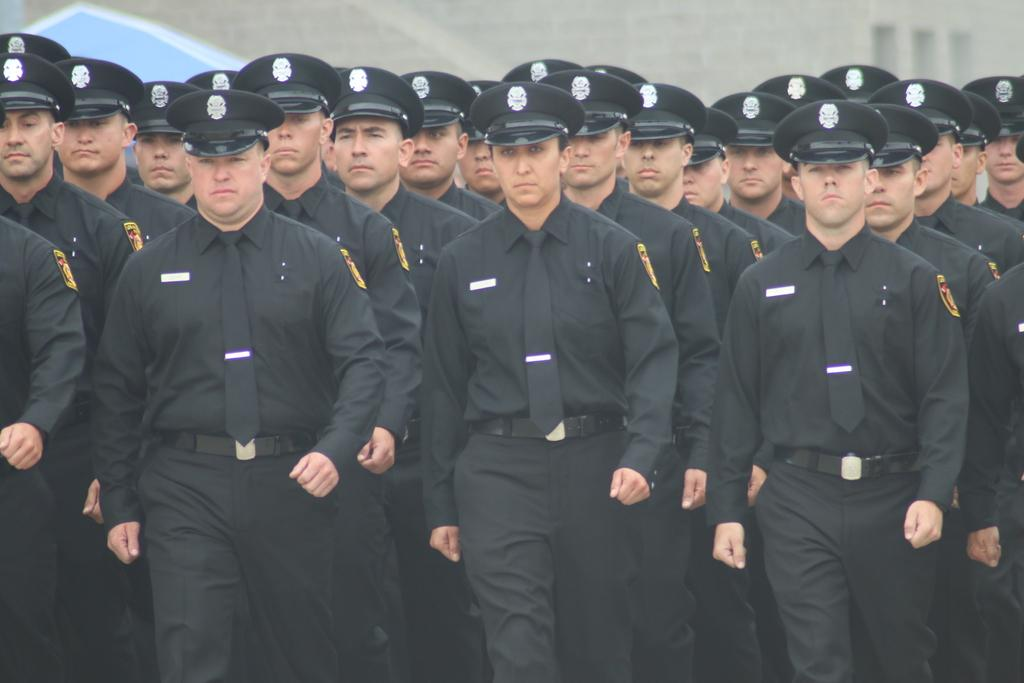What type of people can be seen in the image? There are soldiers in the image. What color are the uniforms worn by the soldiers? The soldiers are wearing black uniforms. What action are the soldiers performing in the image? The soldiers are marching. What type of headgear are the soldiers wearing? The soldiers are wearing black hats. What can be seen in the background of the image? There is a building in the background of the image. What type of ear can be seen on the soldiers in the image? There are no ears visible on the soldiers in the image. 